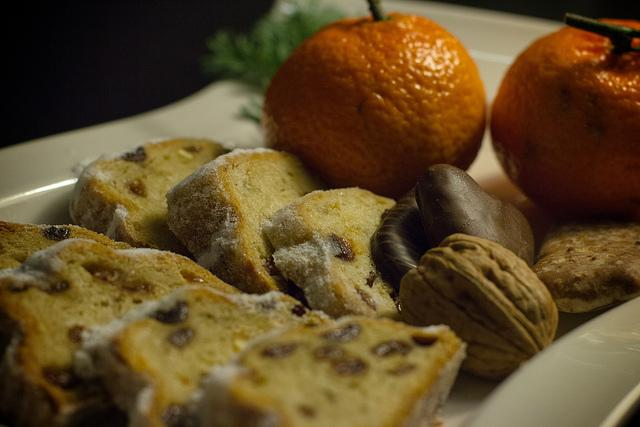What is the name of the nut on the plate? walnut 